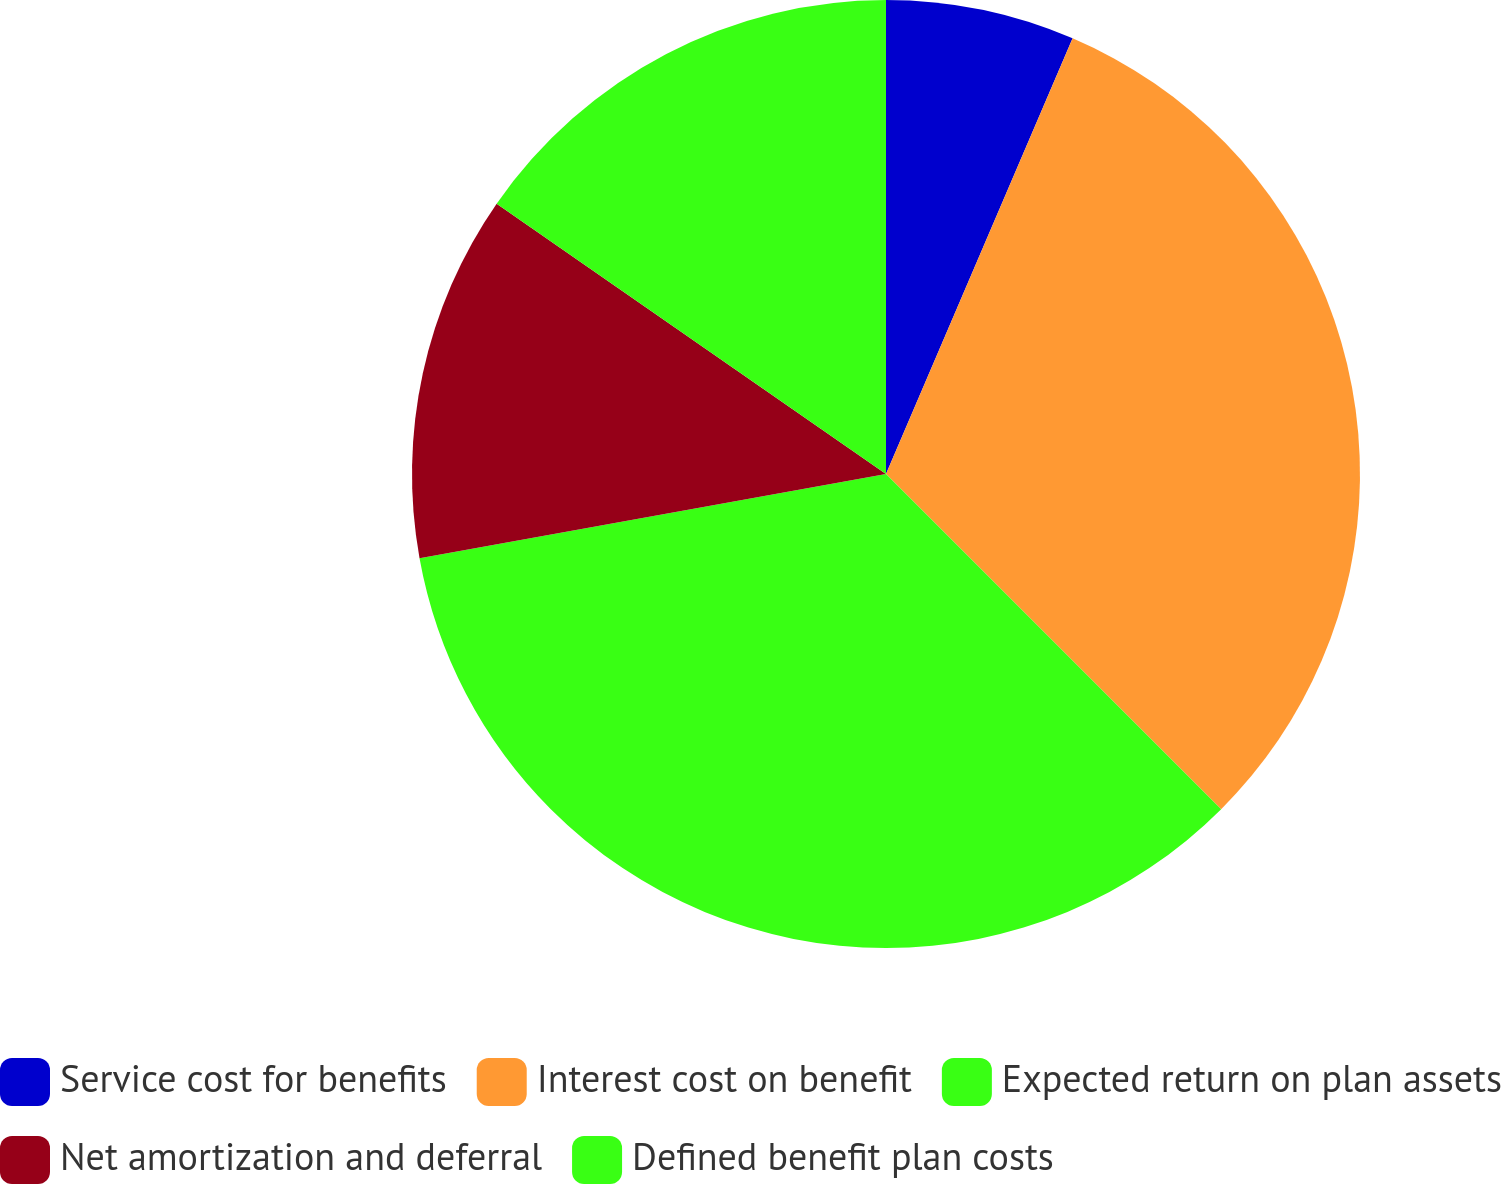Convert chart. <chart><loc_0><loc_0><loc_500><loc_500><pie_chart><fcel>Service cost for benefits<fcel>Interest cost on benefit<fcel>Expected return on plan assets<fcel>Net amortization and deferral<fcel>Defined benefit plan costs<nl><fcel>6.44%<fcel>31.06%<fcel>34.66%<fcel>12.5%<fcel>15.34%<nl></chart> 